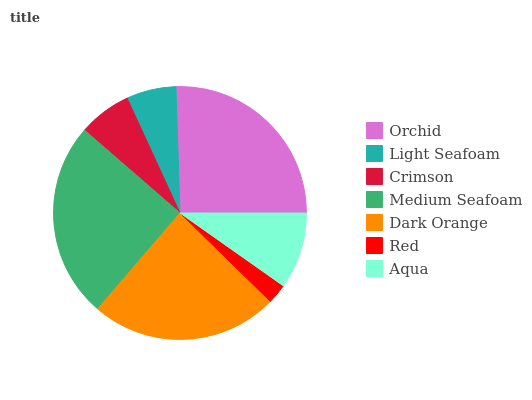Is Red the minimum?
Answer yes or no. Yes. Is Orchid the maximum?
Answer yes or no. Yes. Is Light Seafoam the minimum?
Answer yes or no. No. Is Light Seafoam the maximum?
Answer yes or no. No. Is Orchid greater than Light Seafoam?
Answer yes or no. Yes. Is Light Seafoam less than Orchid?
Answer yes or no. Yes. Is Light Seafoam greater than Orchid?
Answer yes or no. No. Is Orchid less than Light Seafoam?
Answer yes or no. No. Is Aqua the high median?
Answer yes or no. Yes. Is Aqua the low median?
Answer yes or no. Yes. Is Crimson the high median?
Answer yes or no. No. Is Crimson the low median?
Answer yes or no. No. 